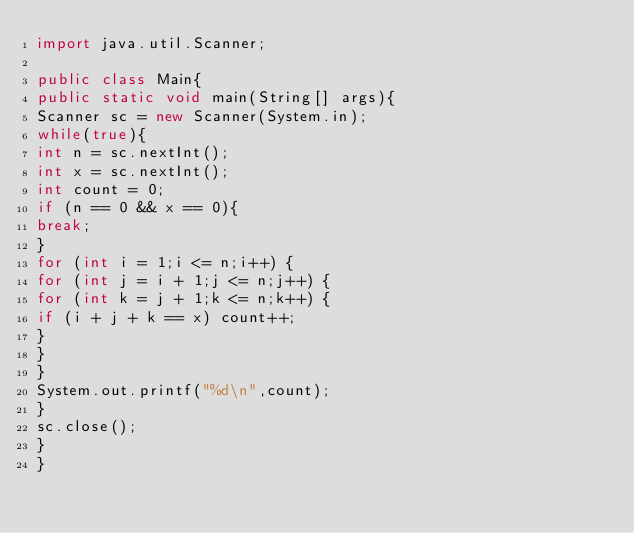<code> <loc_0><loc_0><loc_500><loc_500><_Java_>import java.util.Scanner;

public class Main{
public static void main(String[] args){
Scanner sc = new Scanner(System.in);
while(true){
int n = sc.nextInt();
int x = sc.nextInt();
int count = 0;
if (n == 0 && x == 0){
break;
}
for (int i = 1;i <= n;i++) {
for (int j = i + 1;j <= n;j++) {
for (int k = j + 1;k <= n;k++) {
if (i + j + k == x) count++;
}
}
}
System.out.printf("%d\n",count);
}
sc.close();
}
}
</code> 